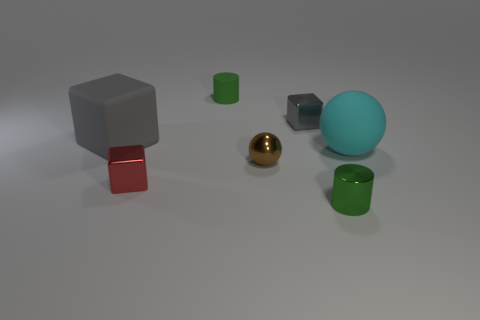How many gray blocks must be subtracted to get 1 gray blocks? 1 Subtract all matte blocks. How many blocks are left? 2 Subtract 0 gray cylinders. How many objects are left? 7 Subtract all cubes. How many objects are left? 4 Subtract 2 balls. How many balls are left? 0 Subtract all cyan blocks. Subtract all blue cylinders. How many blocks are left? 3 Subtract all red cylinders. How many brown balls are left? 1 Subtract all big cyan spheres. Subtract all small cubes. How many objects are left? 4 Add 7 green matte cylinders. How many green matte cylinders are left? 8 Add 5 green shiny cylinders. How many green shiny cylinders exist? 6 